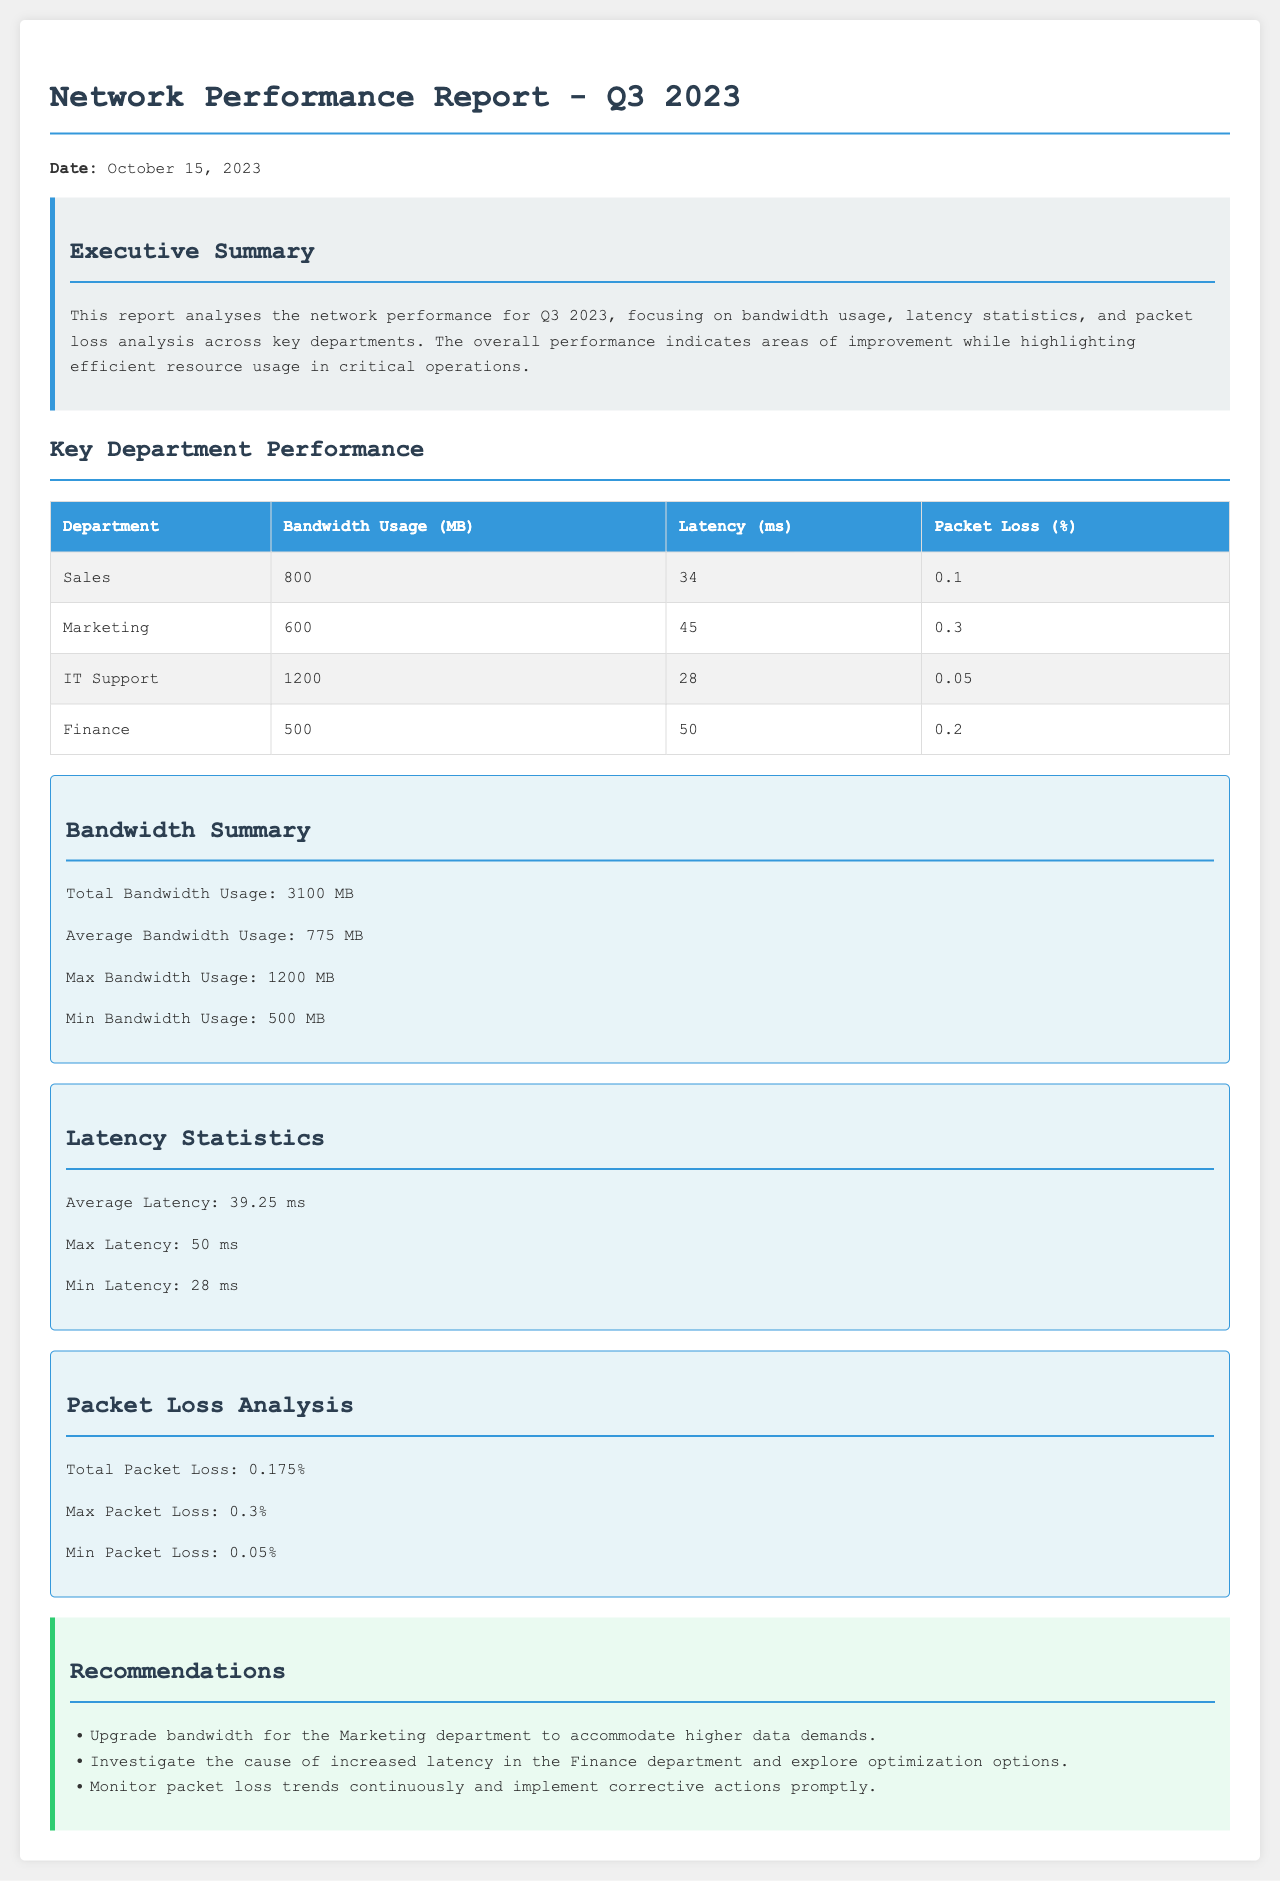What is the total bandwidth usage? The total bandwidth usage is the sum of all the bandwidth usage across the departments reported in the document: 800 + 600 + 1200 + 500 = 3100 MB.
Answer: 3100 MB What is the average latency reported? The average latency is calculated from the individual latencies of the departments: (34 + 45 + 28 + 50) / 4 = 39.25 ms.
Answer: 39.25 ms Which department had the maximum bandwidth usage? The department with the maximum bandwidth usage is identified in the performance table. The IT Support department uses the most bandwidth at 1200 MB.
Answer: IT Support What was the packet loss percentage for Marketing? The packet loss percentage for the Marketing department is explicitly stated in the table. The document shows it as 0.3%.
Answer: 0.3% What is the recommendation for the Marketing department? The recommendations section includes specific suggestions for departments, indicating that the Marketing department needs an upgrade in bandwidth.
Answer: Upgrade bandwidth What is the minimum latency recorded? The minimum latency reported is found in the Latency Statistics section, specifically indicated in the given data. It is noted as 28 ms.
Answer: 28 ms What was the maximum packet loss percentage reported? The maximum packet loss percentage can be found in the Packet Loss Analysis section, which states it clearly. It is 0.3%.
Answer: 0.3% How many departments are included in the performance table? The performance table lists all key departments assessed in the report. There are four departments mentioned: Sales, Marketing, IT Support, and Finance.
Answer: Four What is the date of the report? The date of the report is provided directly at the beginning of the document. It is October 15, 2023.
Answer: October 15, 2023 